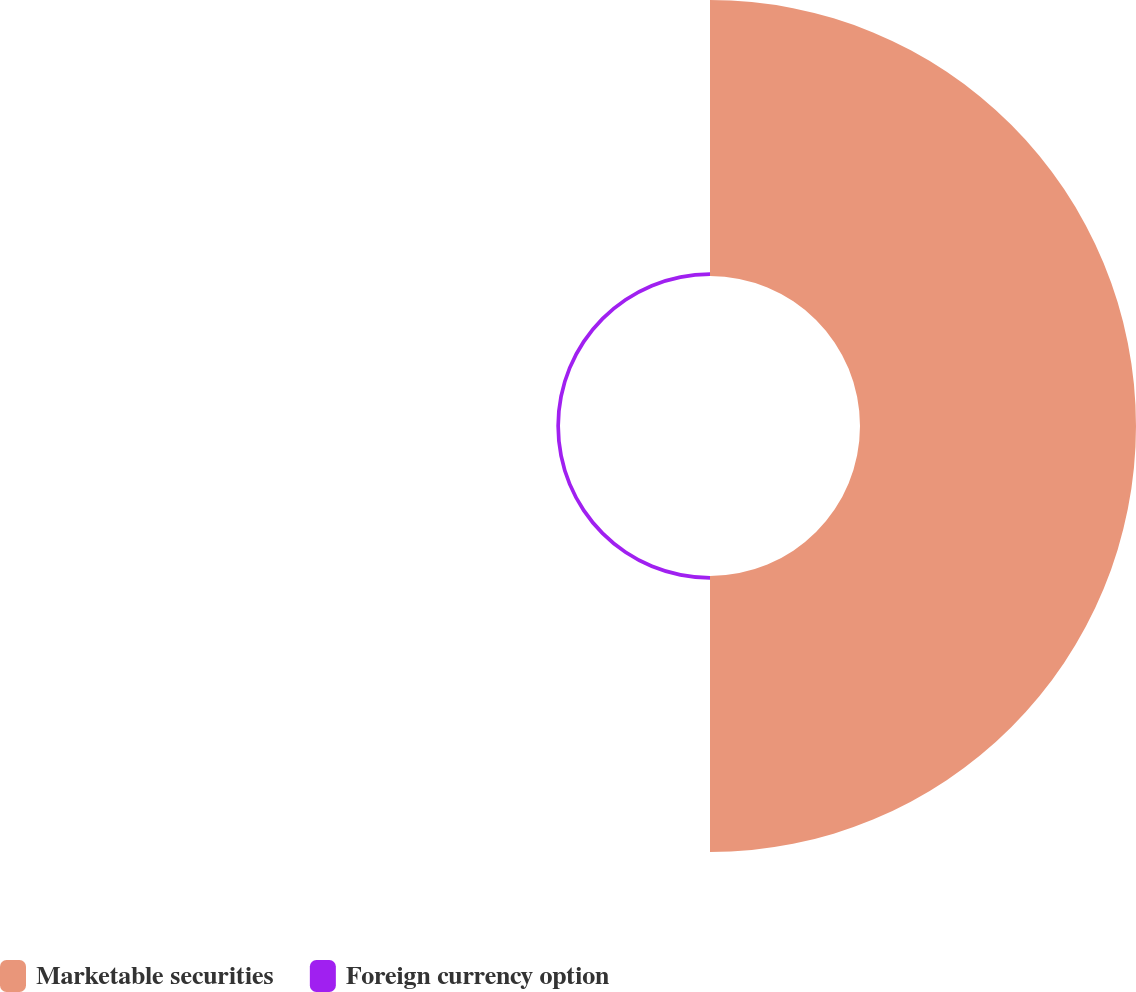Convert chart to OTSL. <chart><loc_0><loc_0><loc_500><loc_500><pie_chart><fcel>Marketable securities<fcel>Foreign currency option<nl><fcel>98.68%<fcel>1.32%<nl></chart> 